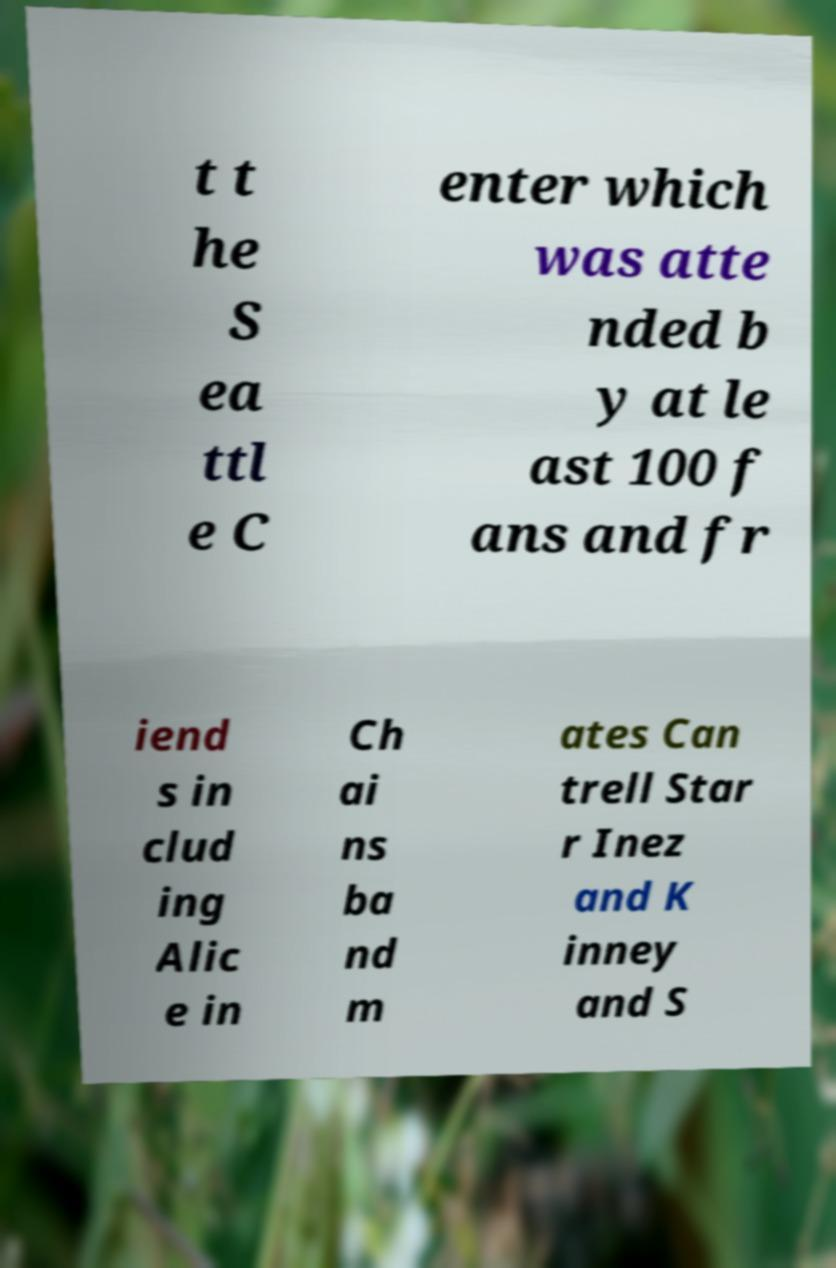Can you accurately transcribe the text from the provided image for me? t t he S ea ttl e C enter which was atte nded b y at le ast 100 f ans and fr iend s in clud ing Alic e in Ch ai ns ba nd m ates Can trell Star r Inez and K inney and S 